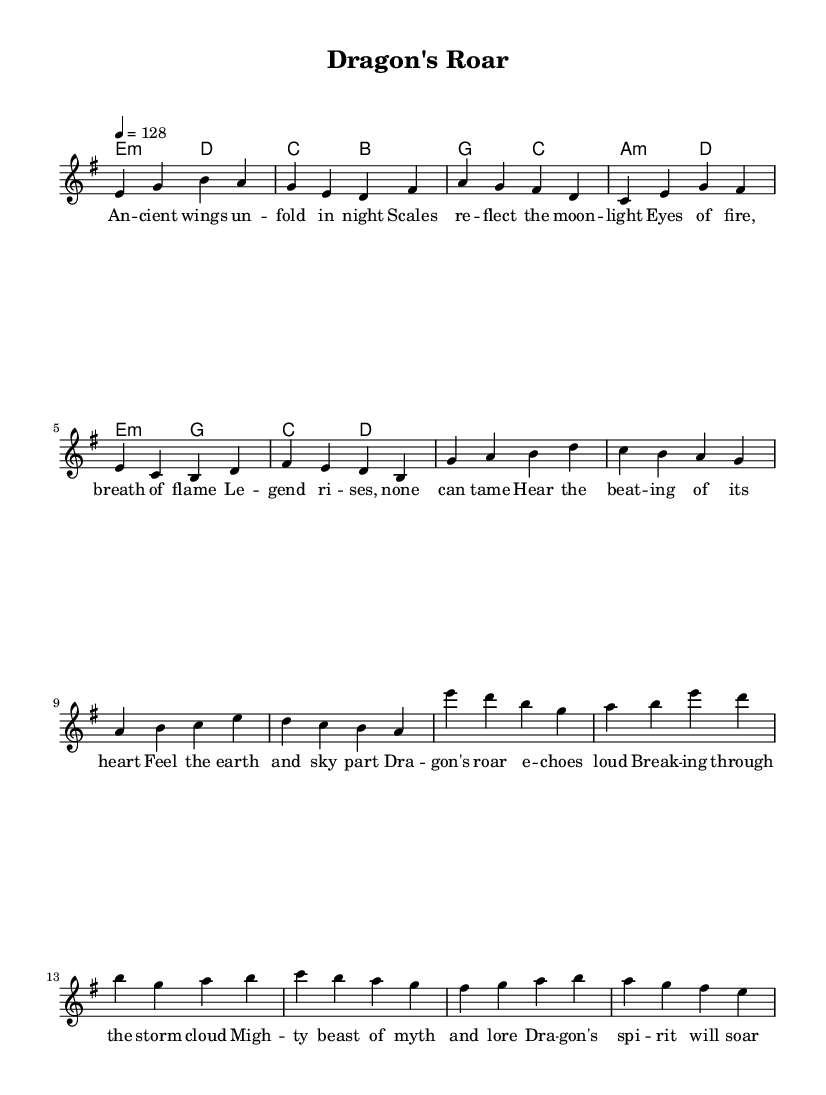What is the key signature of this music? The key signature is E minor, which indicates the piece contains one sharp (F#) and sets the tonal center around E.
Answer: E minor What is the time signature of this music? The time signature is 4/4, which means there are four beats in each measure, with each quarter note receiving one beat.
Answer: 4/4 What is the tempo marking for this piece? The tempo marking is 4 = 128, which signifies that there are 128 beats per minute in a quarter note.
Answer: 128 How many lines are in the staff for the melody? The staff for the melody contains five lines, which is standard for traditional Western musical notation.
Answer: Five What is the structure of this music based on sections? The structure includes a Verse, Pre-Chorus, and Chorus, indicating a typical pop song format that develops themes over different sections.
Answer: Verse, Pre-Chorus, Chorus Which mythical creature is featured in the lyrics? The lyrics prominently feature a dragon, which is associated with themes of power and legend in many cultures.
Answer: Dragon What is the emotional tone conveyed in the chorus? The chorus conveys an emotional tone of strength and empowerment, invoking imagery of a mighty legendary creature overcoming obstacles like a storm.
Answer: Strength and empowerment 